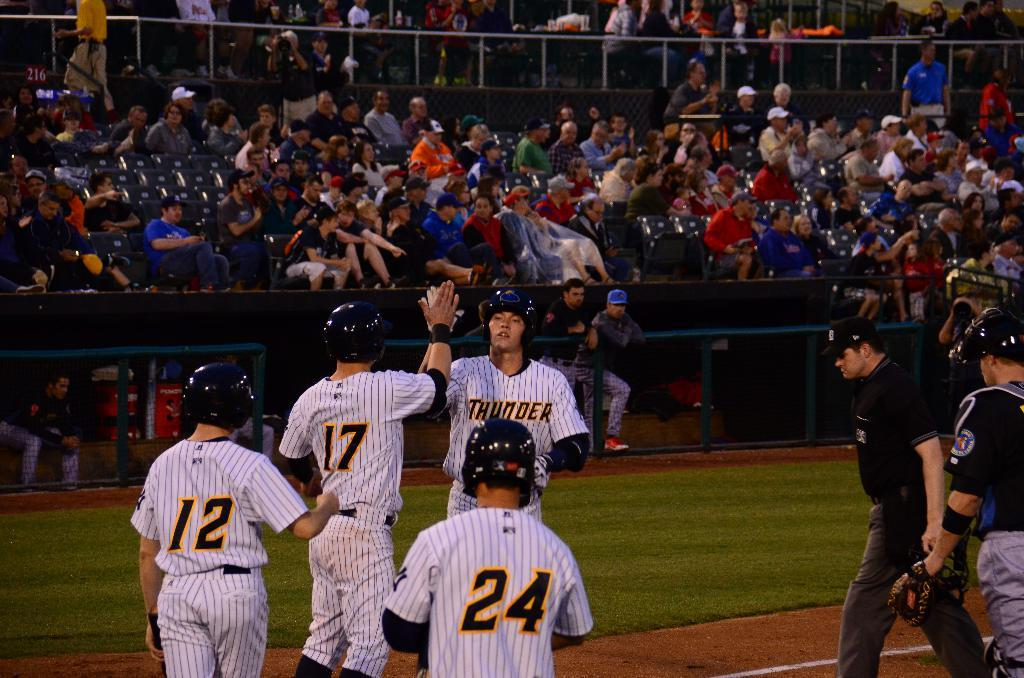Provide a one-sentence caption for the provided image. The team Thunder is playing on the field. 